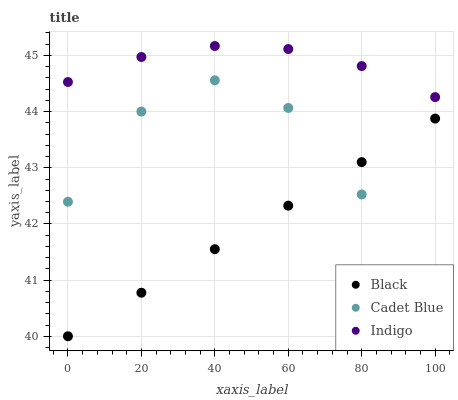Does Black have the minimum area under the curve?
Answer yes or no. Yes. Does Indigo have the maximum area under the curve?
Answer yes or no. Yes. Does Cadet Blue have the minimum area under the curve?
Answer yes or no. No. Does Cadet Blue have the maximum area under the curve?
Answer yes or no. No. Is Black the smoothest?
Answer yes or no. Yes. Is Cadet Blue the roughest?
Answer yes or no. Yes. Is Cadet Blue the smoothest?
Answer yes or no. No. Is Black the roughest?
Answer yes or no. No. Does Cadet Blue have the lowest value?
Answer yes or no. Yes. Does Indigo have the highest value?
Answer yes or no. Yes. Does Cadet Blue have the highest value?
Answer yes or no. No. Is Black less than Indigo?
Answer yes or no. Yes. Is Indigo greater than Cadet Blue?
Answer yes or no. Yes. Does Cadet Blue intersect Black?
Answer yes or no. Yes. Is Cadet Blue less than Black?
Answer yes or no. No. Is Cadet Blue greater than Black?
Answer yes or no. No. Does Black intersect Indigo?
Answer yes or no. No. 